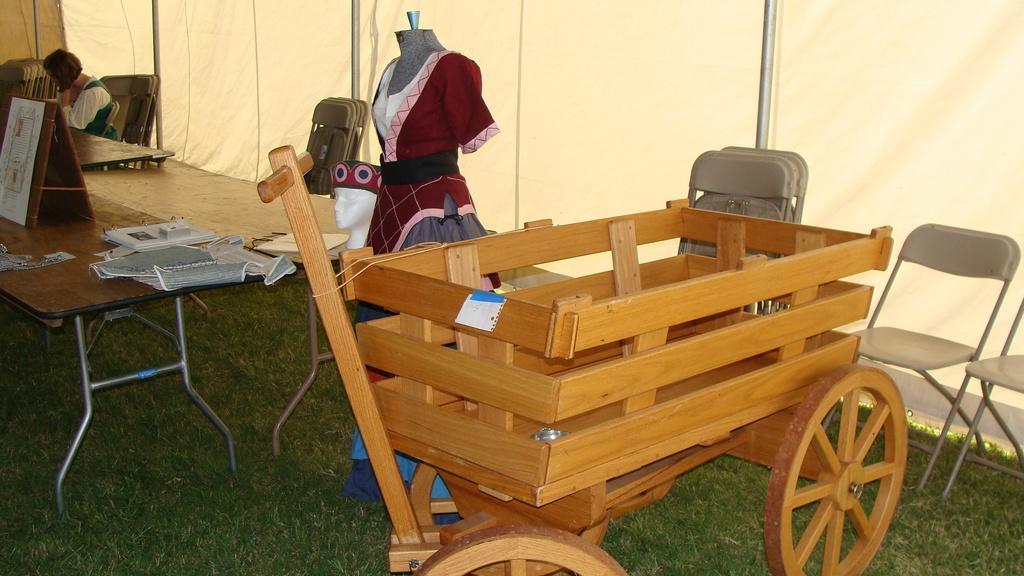Can you describe this image briefly? In the picture we can see some cart, chairs, table and some dress and one woman. In the background we can find a curtain wall. 